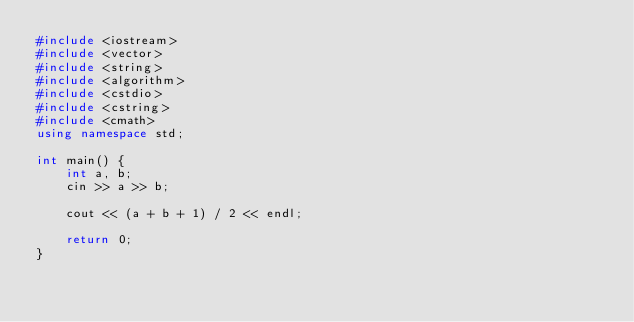<code> <loc_0><loc_0><loc_500><loc_500><_C++_>#include <iostream>
#include <vector>
#include <string>
#include <algorithm>
#include <cstdio>
#include <cstring>
#include <cmath>
using namespace std;

int main() {
    int a, b;
    cin >> a >> b;

    cout << (a + b + 1) / 2 << endl;

    return 0;
}</code> 